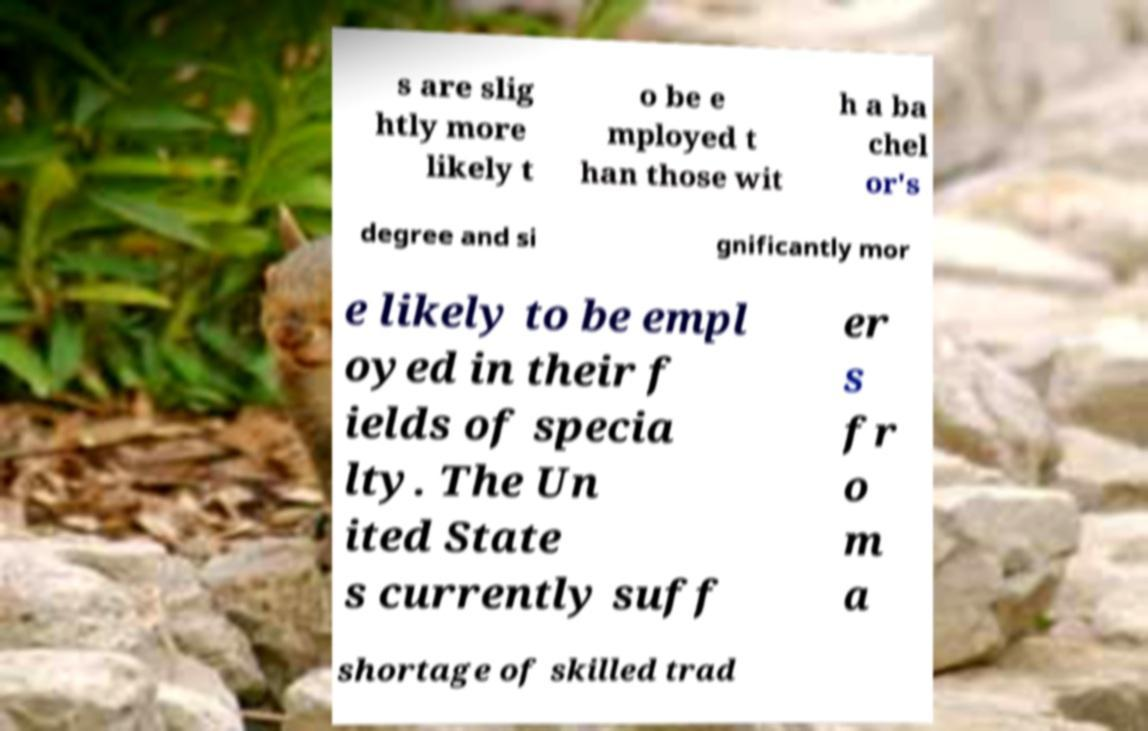There's text embedded in this image that I need extracted. Can you transcribe it verbatim? s are slig htly more likely t o be e mployed t han those wit h a ba chel or's degree and si gnificantly mor e likely to be empl oyed in their f ields of specia lty. The Un ited State s currently suff er s fr o m a shortage of skilled trad 